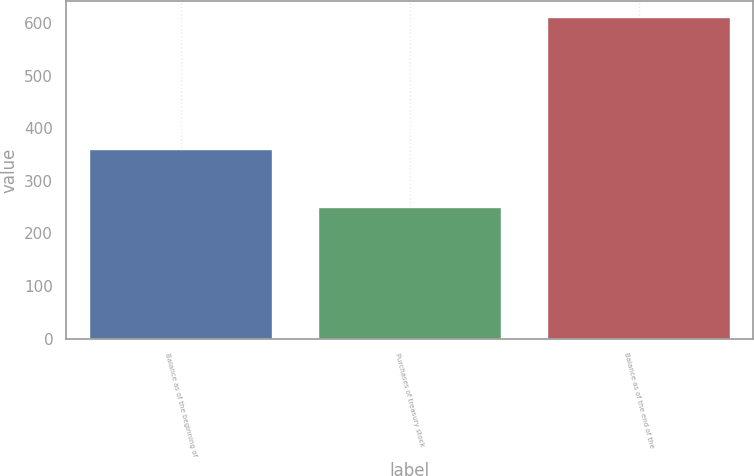Convert chart. <chart><loc_0><loc_0><loc_500><loc_500><bar_chart><fcel>Balance as of the beginning of<fcel>Purchases of treasury stock<fcel>Balance as of the end of the<nl><fcel>361<fcel>250<fcel>611<nl></chart> 